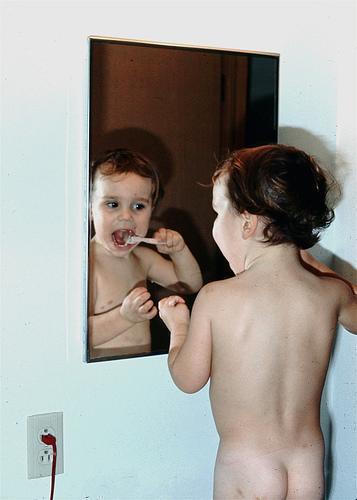How many kids are in the picture?
Give a very brief answer. 1. 